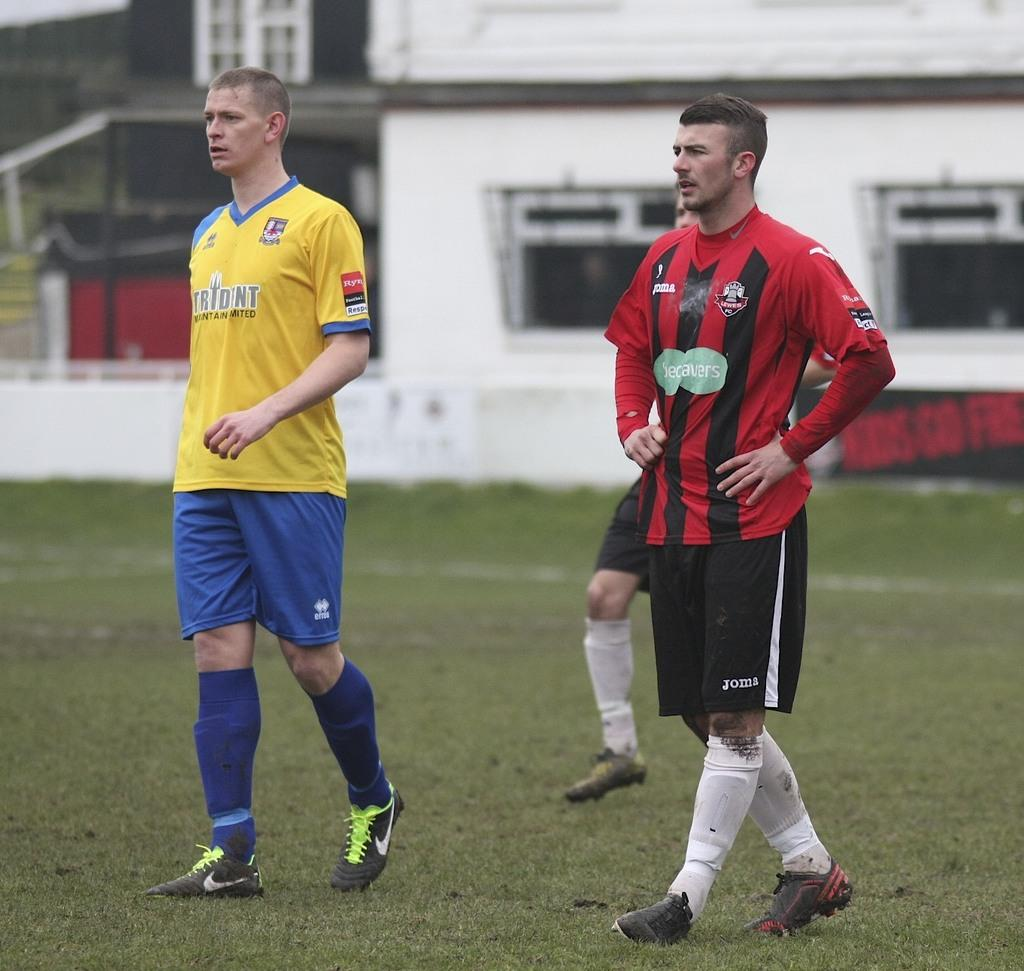<image>
Write a terse but informative summary of the picture. Athlete in yellow andblue uniform with Trident in blue lettering on the front. 